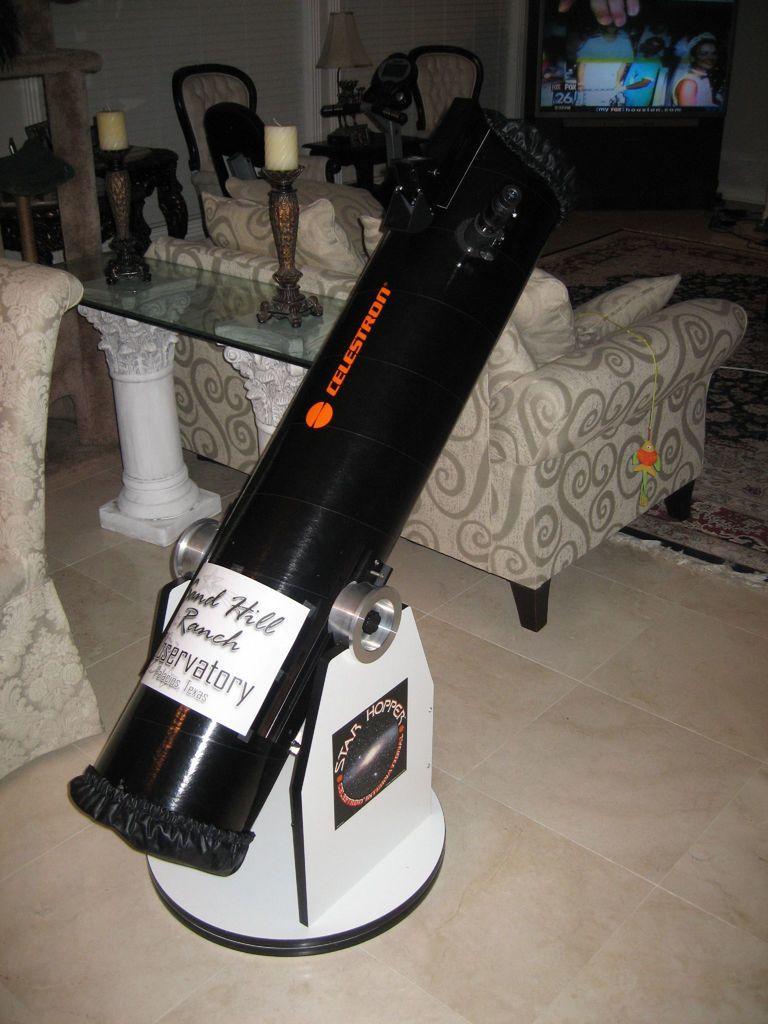Can you describe this image briefly? There are sofas, these are candles and chairs, this is an object, this is floor and a glass. 